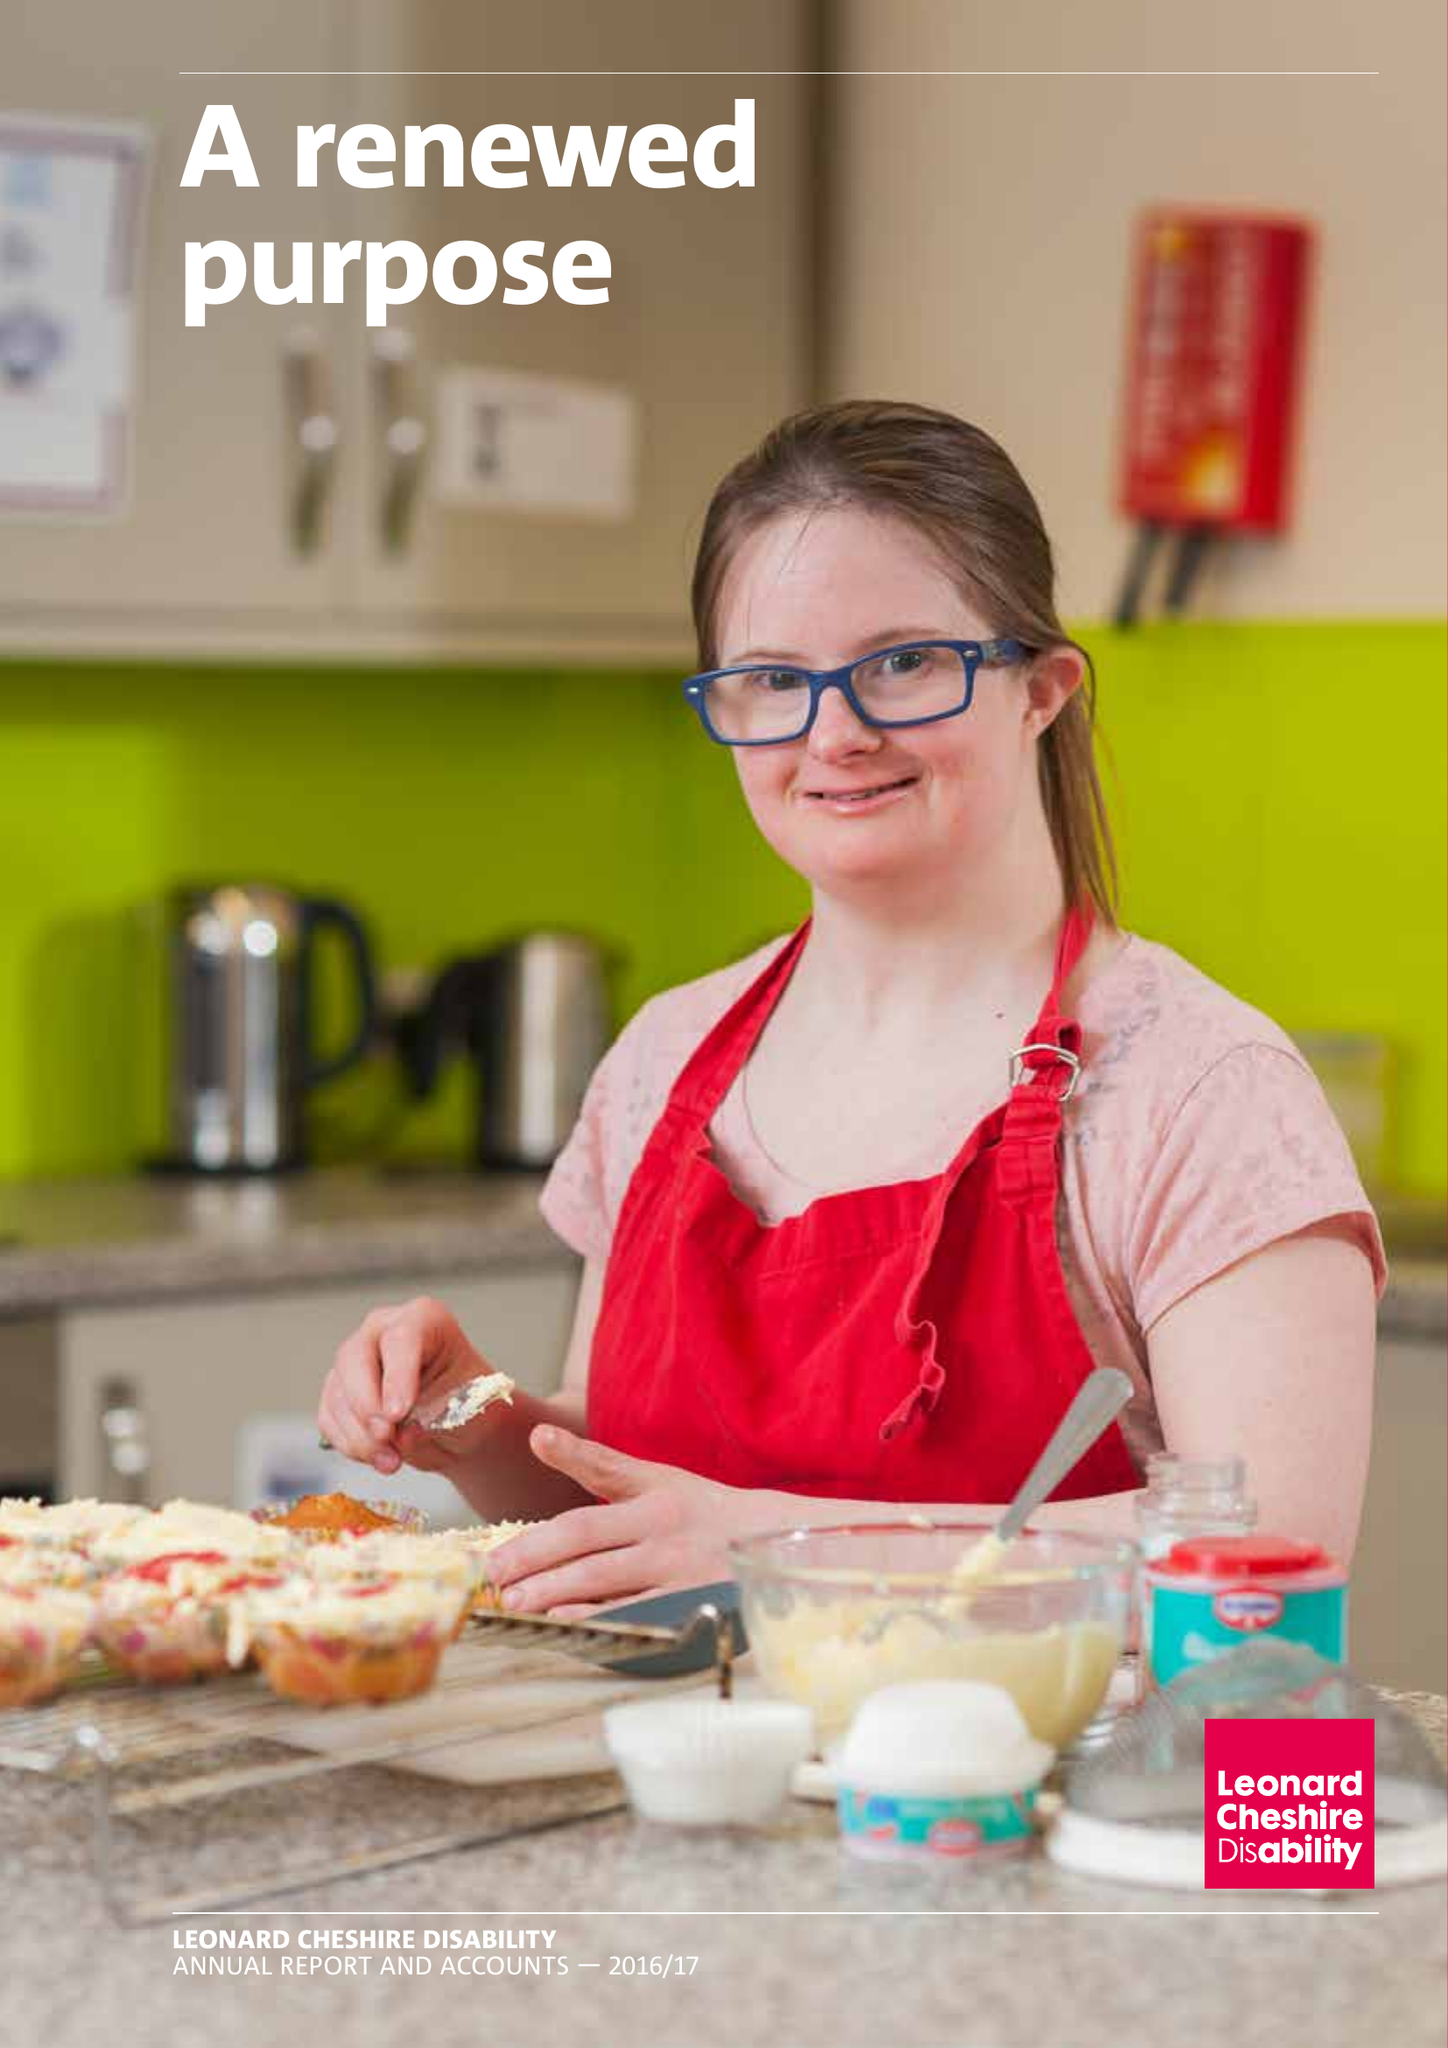What is the value for the address__postcode?
Answer the question using a single word or phrase. SW8 1RL 